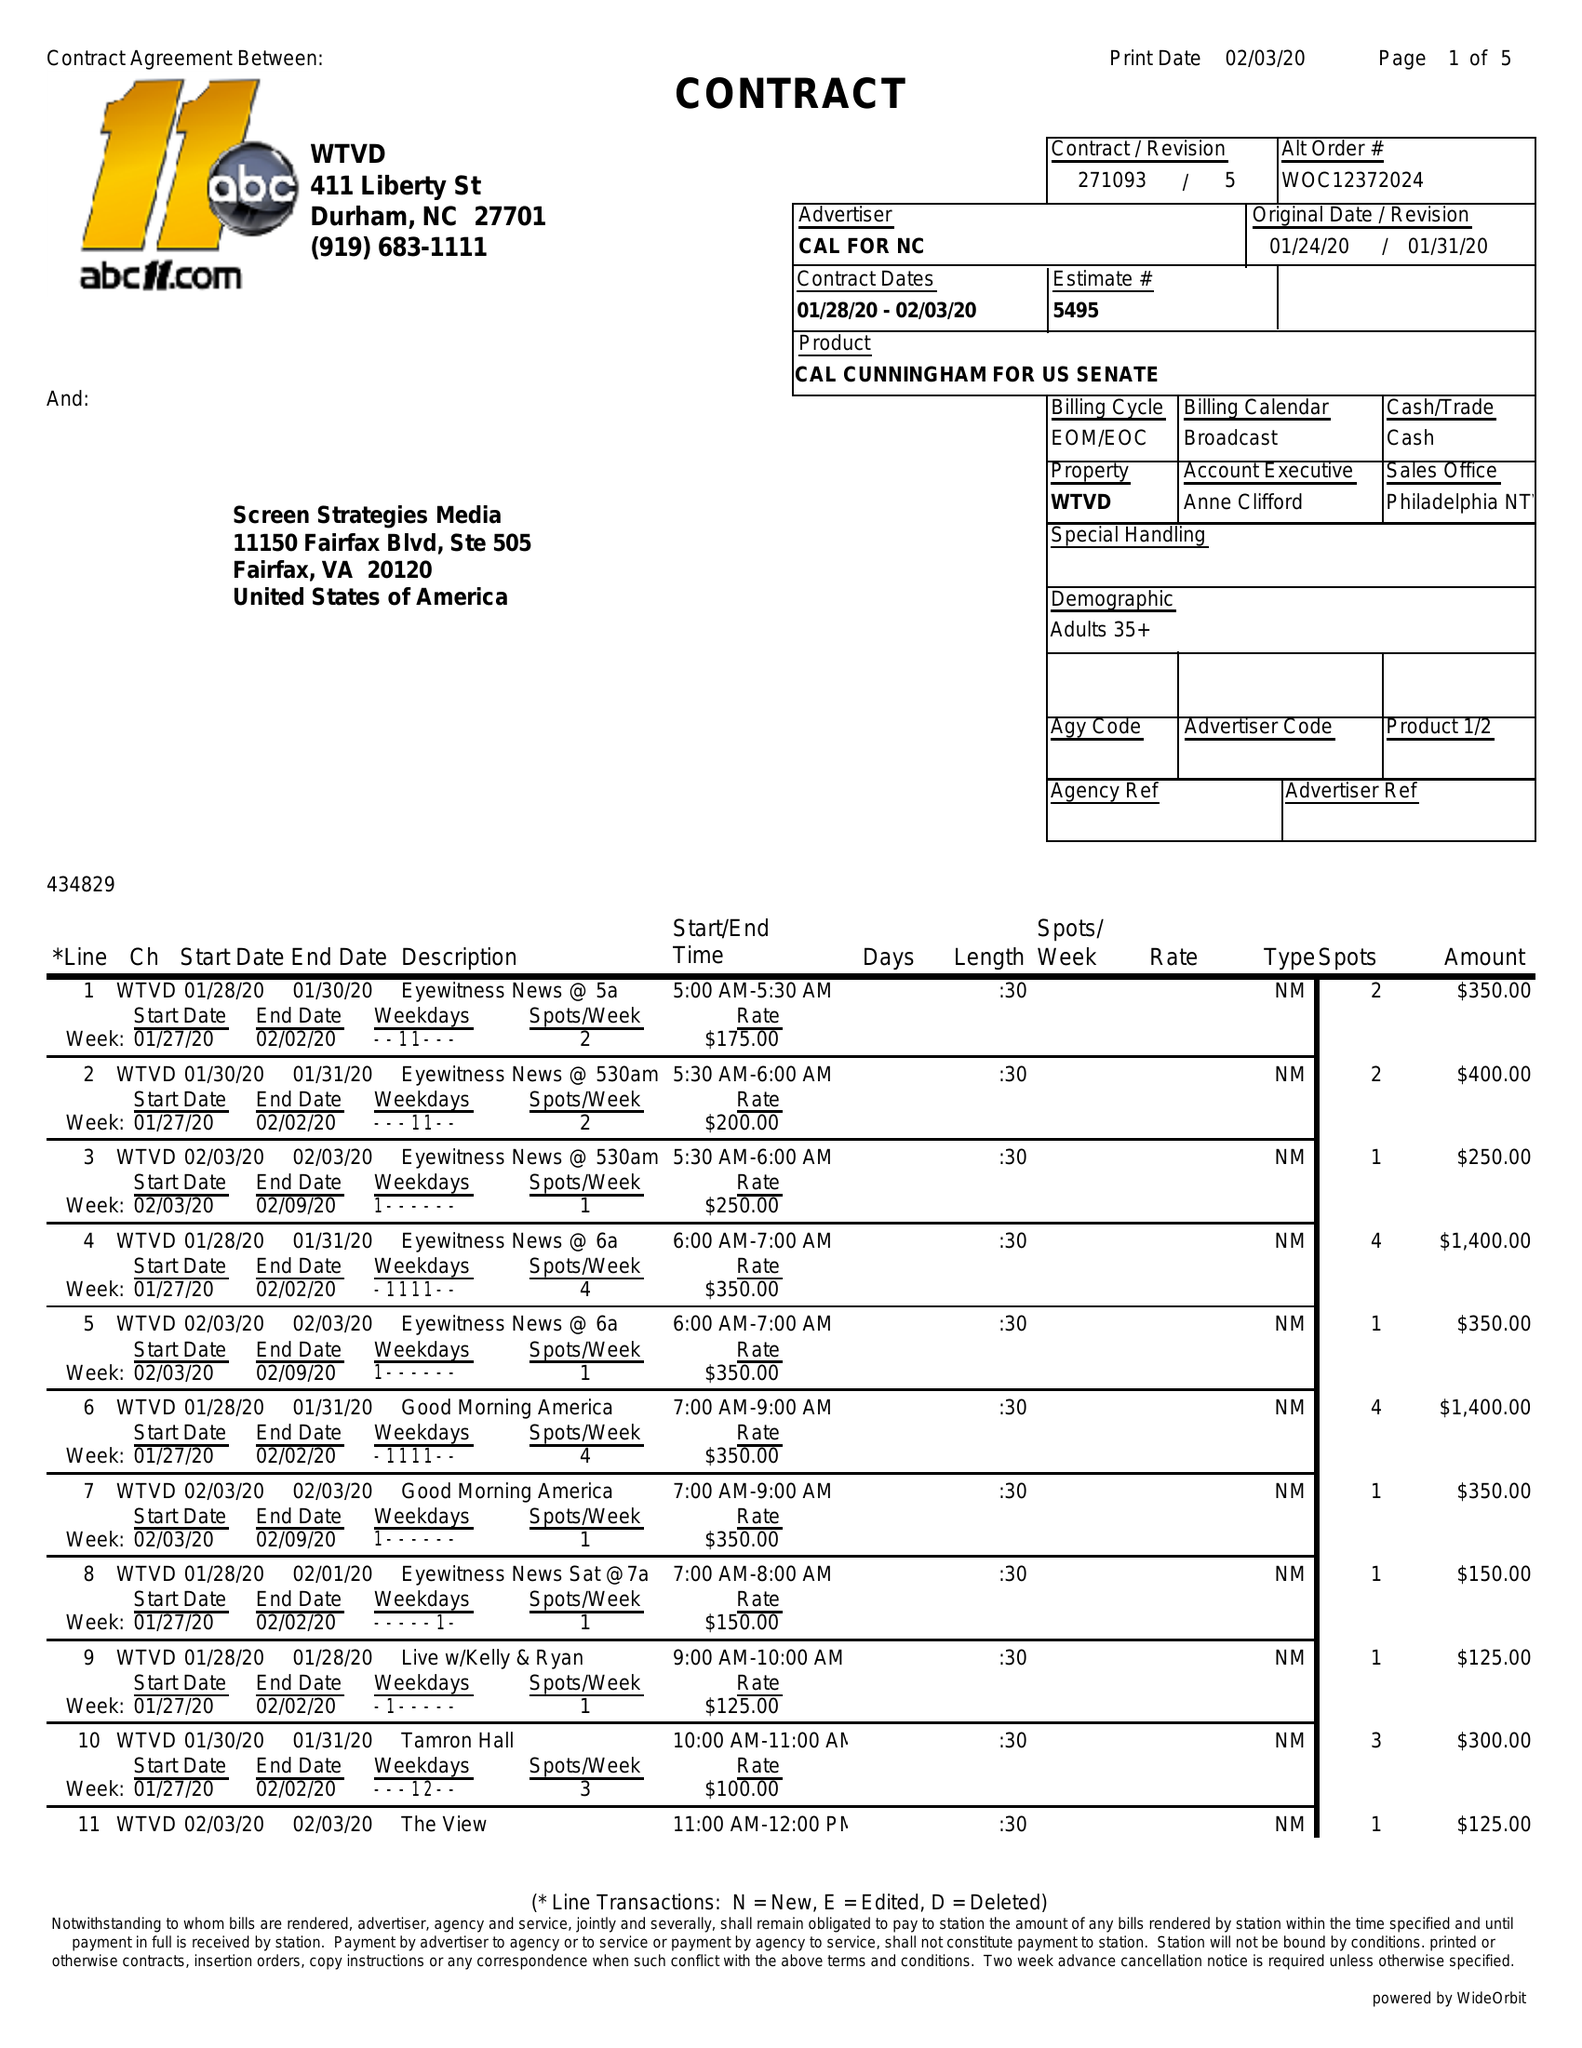What is the value for the flight_to?
Answer the question using a single word or phrase. 02/03/20 